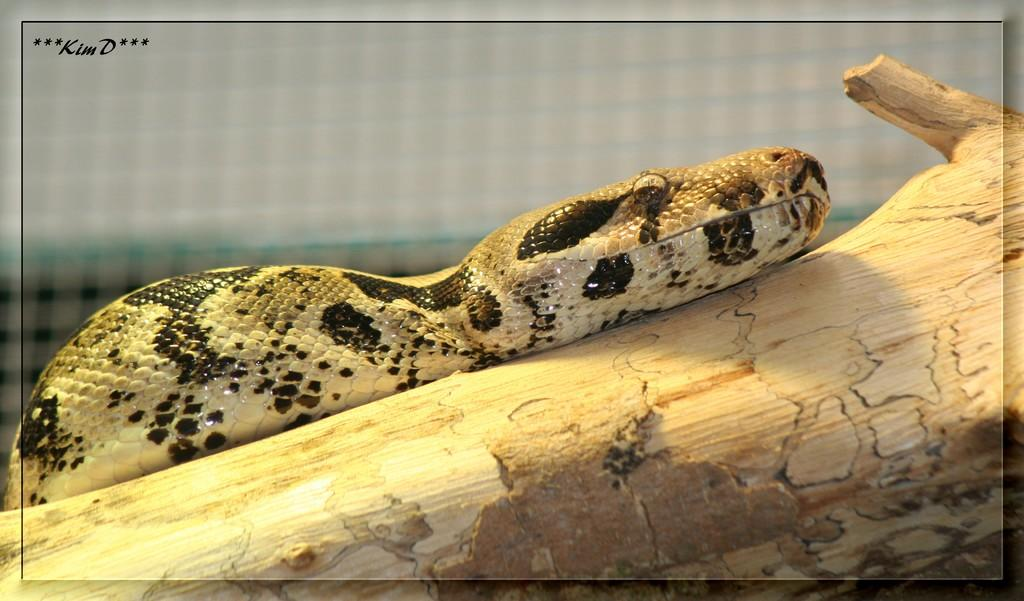What animal is present in the image? There is a snake in the image. What is the snake resting on? The snake is on a wooden object. What can be seen in the background of the image? There appears to be a mesh in the background of the image. What language is the snake speaking in the image? Snakes do not have the ability to speak, so there is no language present in the image. 